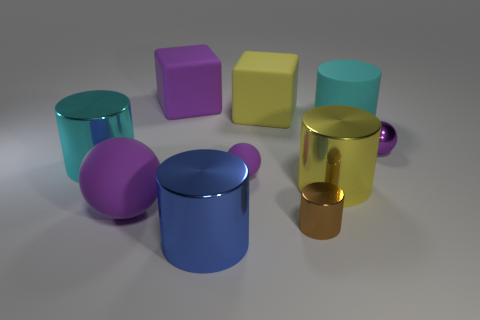Is the color of the large rubber sphere the same as the small rubber sphere?
Your answer should be very brief. Yes. The large rubber thing that is in front of the cyan cylinder to the right of the large blue shiny cylinder is what shape?
Your answer should be very brief. Sphere. There is a cyan cylinder that is right of the large cyan shiny cylinder; what number of big yellow blocks are on the right side of it?
Offer a very short reply. 0. What is the purple object that is both behind the large cyan shiny cylinder and in front of the purple cube made of?
Provide a short and direct response. Metal. What shape is the matte object that is the same size as the purple metallic sphere?
Offer a very short reply. Sphere. The tiny metallic thing in front of the cyan object that is on the left side of the big cyan cylinder that is to the right of the big purple rubber sphere is what color?
Ensure brevity in your answer.  Brown. How many things are big rubber cubes right of the blue cylinder or tiny metal objects?
Your answer should be compact. 3. There is a yellow cylinder that is the same size as the blue metallic thing; what material is it?
Your response must be concise. Metal. There is a big cylinder in front of the large matte object in front of the large metallic object that is behind the big yellow metallic object; what is it made of?
Ensure brevity in your answer.  Metal. The big ball has what color?
Make the answer very short. Purple. 